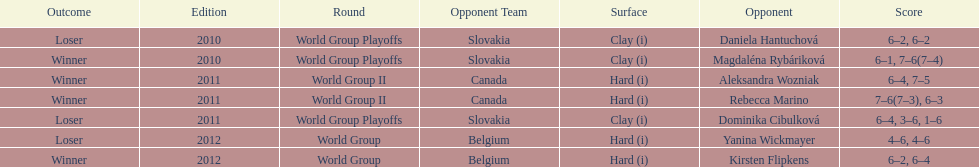What game came after the world group ii rounds in the list? World Group Playoffs. 